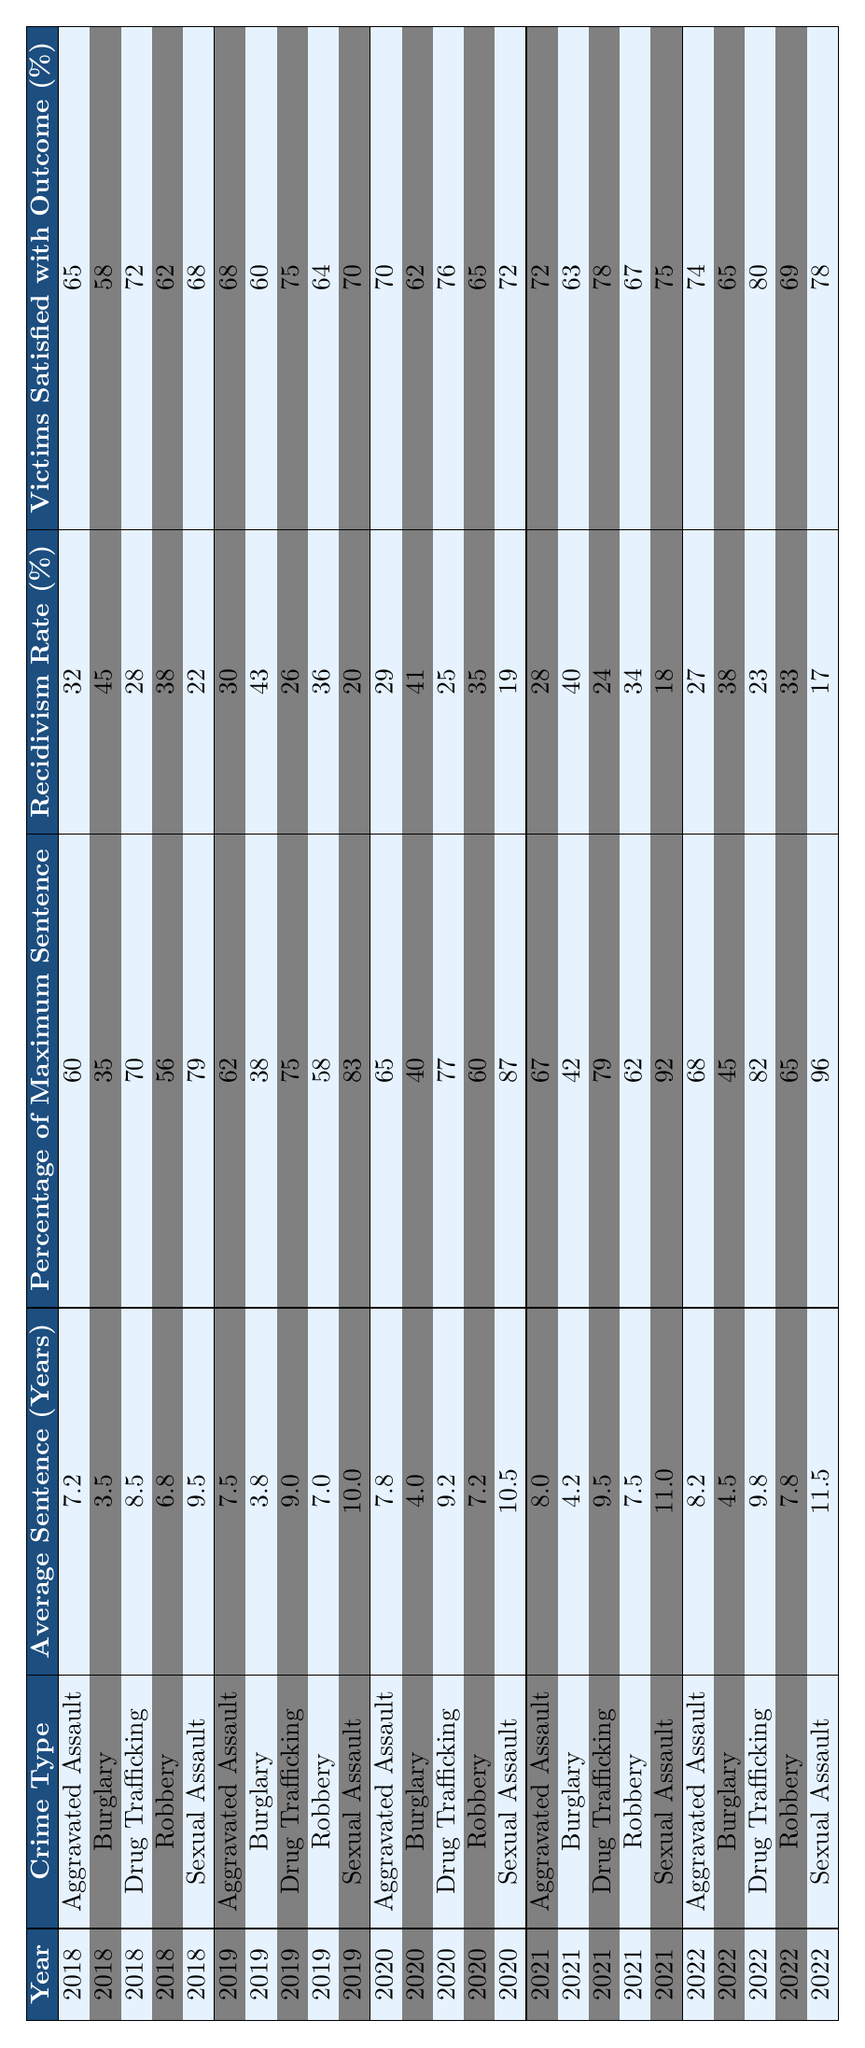What was the average sentence for Drug Trafficking in 2020? The average sentence for Drug Trafficking in 2020 is directly provided in the table, which indicates it is 9.2 years.
Answer: 9.2 years In which year did Sexual Assault have the highest average sentence? By examining the table, we see that the average sentence for Sexual Assault is highest in 2022 at 11.5 years, compared to 11.0 years in 2021 and 10.5 years in 2020.
Answer: 2022 What is the percentage of victims satisfied with the outcome in 2019 for Burglary? The table shows that for Burglary in 2019, 60% of victims were satisfied with the outcome.
Answer: 60% How does the recidivism rate for Aggravated Assault in 2021 compare to that in 2018? From the table, the recidivism rate for Aggravated Assault in 2021 is 28%, while in 2018 it is 32%. This means the rate decreased by 4 percentage points from 2018 to 2021.
Answer: It decreased by 4 percentage points What was the change in the average sentence for Robbery from 2018 to 2022? The average sentence for Robbery in 2018 was 6.8 years, and in 2022 it was 7.8 years. The change can be calculated as 7.8 - 6.8 = 1.0 year, indicating an increase.
Answer: Increased by 1.0 year What was the average percentage of maximum sentence for Drug Trafficking across all five years? To find the average percentage of maximum sentence for Drug Trafficking, sum the percentages for each year (70, 75, 77, 79, 82) and divide by the number of years: (70 + 75 + 77 + 79 + 82) / 5 = 76.6%.
Answer: 76.6% Did the percentage of victims satisfied with the outcome increase for Sexual Assault from 2018 to 2022? Looking at the table, the percentage for Sexual Assault was 68% in 2018 and increased to 78% in 2022, which shows a positive change.
Answer: Yes, it increased Which crime type had the highest average sentence over the five years listed? By evaluating the average sentences from each crime type over the five years, Sexual Assault consistently has the highest average sentence of 11.1 years when calculated (9.5, 10.0, 10.5, 11.0, 11.5).
Answer: Sexual Assault What is the average recidivism rate for Burglary over the five years? The recidivism rates for Burglary for each year are 45%, 43%, 41%, 40%, and 38%. The average is (45 + 43 + 41 + 40 + 38) / 5 = 41.4%.
Answer: 41.4% Was there a year when the average sentence for Aggravated Assault was lower than 7.5 years? Checking the table shows that in 2018, the average sentence was 7.2 years, which is indeed lower than 7.5 years.
Answer: Yes, in 2018 What trend can be seen in the percentage of victims satisfied with outcomes for Drug Trafficking from 2018 to 2022? If we look at the percentages for Drug Trafficking, they are (72, 75, 76, 78, 80), showing a consistent increase over the years.
Answer: The trend is an increase 